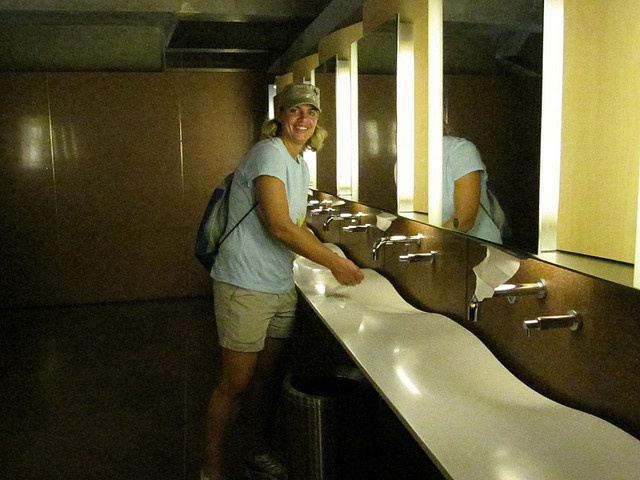Describe the objects in this image and their specific colors. I can see people in black, olive, and gray tones, sink in black, tan, and khaki tones, sink in black, tan, and khaki tones, handbag in black and darkgreen tones, and backpack in black and darkgreen tones in this image. 